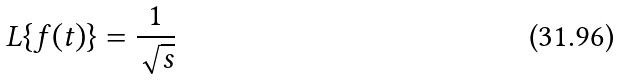Convert formula to latex. <formula><loc_0><loc_0><loc_500><loc_500>L \{ f ( t ) \} = \frac { 1 } { \sqrt { s } }</formula> 